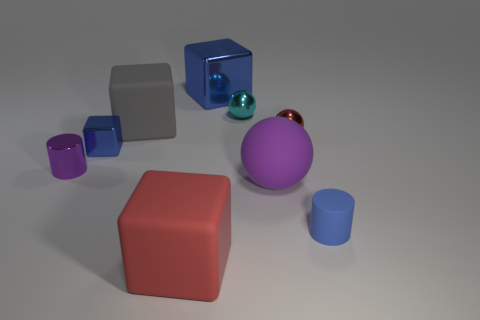Add 1 small metal balls. How many objects exist? 10 Subtract all spheres. How many objects are left? 6 Add 9 purple balls. How many purple balls exist? 10 Subtract 1 purple balls. How many objects are left? 8 Subtract all small blue spheres. Subtract all gray matte things. How many objects are left? 8 Add 8 purple spheres. How many purple spheres are left? 9 